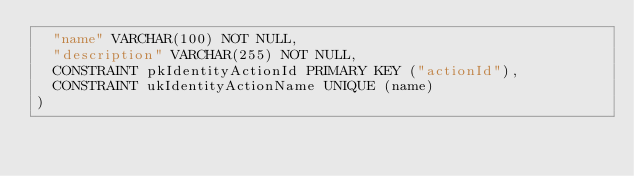Convert code to text. <code><loc_0><loc_0><loc_500><loc_500><_SQL_>  "name" VARCHAR(100) NOT NULL,
  "description" VARCHAR(255) NOT NULL,
  CONSTRAINT pkIdentityActionId PRIMARY KEY ("actionId"),
  CONSTRAINT ukIdentityActionName UNIQUE (name)
)
</code> 